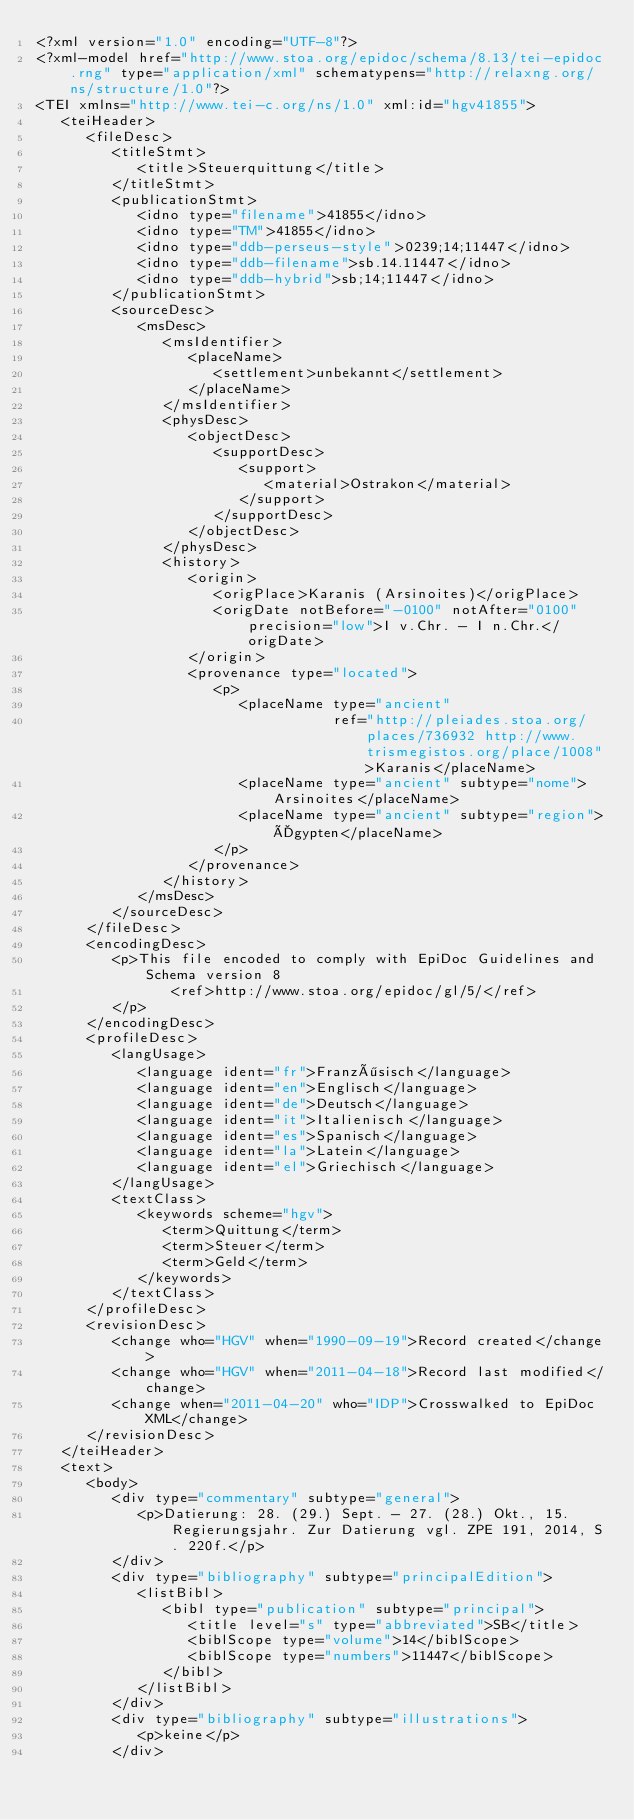<code> <loc_0><loc_0><loc_500><loc_500><_XML_><?xml version="1.0" encoding="UTF-8"?>
<?xml-model href="http://www.stoa.org/epidoc/schema/8.13/tei-epidoc.rng" type="application/xml" schematypens="http://relaxng.org/ns/structure/1.0"?>
<TEI xmlns="http://www.tei-c.org/ns/1.0" xml:id="hgv41855">
   <teiHeader>
      <fileDesc>
         <titleStmt>
            <title>Steuerquittung</title>
         </titleStmt>
         <publicationStmt>
            <idno type="filename">41855</idno>
            <idno type="TM">41855</idno>
            <idno type="ddb-perseus-style">0239;14;11447</idno>
            <idno type="ddb-filename">sb.14.11447</idno>
            <idno type="ddb-hybrid">sb;14;11447</idno>
         </publicationStmt>
         <sourceDesc>
            <msDesc>
               <msIdentifier>
                  <placeName>
                     <settlement>unbekannt</settlement>
                  </placeName>
               </msIdentifier>
               <physDesc>
                  <objectDesc>
                     <supportDesc>
                        <support>
                           <material>Ostrakon</material>
                        </support>
                     </supportDesc>
                  </objectDesc>
               </physDesc>
               <history>
                  <origin>
                     <origPlace>Karanis (Arsinoites)</origPlace>
                     <origDate notBefore="-0100" notAfter="0100" precision="low">I v.Chr. - I n.Chr.</origDate>
                  </origin>
                  <provenance type="located">
                     <p>
                        <placeName type="ancient"
                                   ref="http://pleiades.stoa.org/places/736932 http://www.trismegistos.org/place/1008">Karanis</placeName>
                        <placeName type="ancient" subtype="nome">Arsinoites</placeName>
                        <placeName type="ancient" subtype="region">Ägypten</placeName>
                     </p>
                  </provenance>
               </history>
            </msDesc>
         </sourceDesc>
      </fileDesc>
      <encodingDesc>
         <p>This file encoded to comply with EpiDoc Guidelines and Schema version 8
                <ref>http://www.stoa.org/epidoc/gl/5/</ref>
         </p>
      </encodingDesc>
      <profileDesc>
         <langUsage>
            <language ident="fr">Französisch</language>
            <language ident="en">Englisch</language>
            <language ident="de">Deutsch</language>
            <language ident="it">Italienisch</language>
            <language ident="es">Spanisch</language>
            <language ident="la">Latein</language>
            <language ident="el">Griechisch</language>
         </langUsage>
         <textClass>
            <keywords scheme="hgv">
               <term>Quittung</term>
               <term>Steuer</term>
               <term>Geld</term>
            </keywords>
         </textClass>
      </profileDesc>
      <revisionDesc>
         <change who="HGV" when="1990-09-19">Record created</change>
         <change who="HGV" when="2011-04-18">Record last modified</change>
         <change when="2011-04-20" who="IDP">Crosswalked to EpiDoc XML</change>
      </revisionDesc>
   </teiHeader>
   <text>
      <body>
         <div type="commentary" subtype="general">
            <p>Datierung: 28. (29.) Sept. - 27. (28.) Okt., 15. Regierungsjahr. Zur Datierung vgl. ZPE 191, 2014, S. 220f.</p>
         </div>
         <div type="bibliography" subtype="principalEdition">
            <listBibl>
               <bibl type="publication" subtype="principal">
                  <title level="s" type="abbreviated">SB</title>
                  <biblScope type="volume">14</biblScope>
                  <biblScope type="numbers">11447</biblScope>
               </bibl>
            </listBibl>
         </div>
         <div type="bibliography" subtype="illustrations">
            <p>keine</p>
         </div></code> 